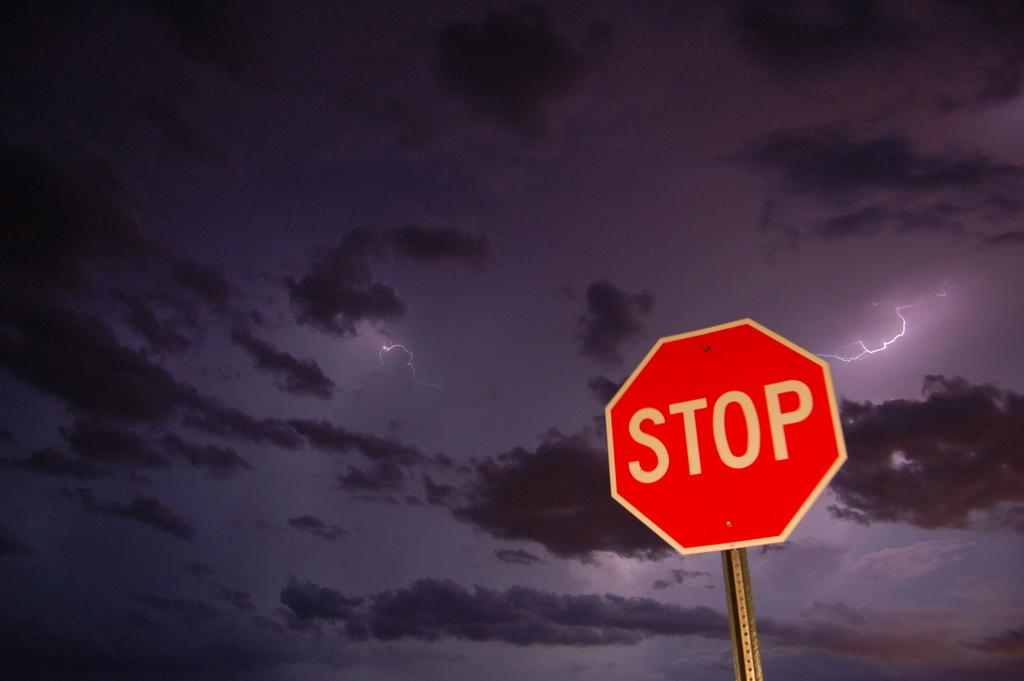What is the main object in the image? There is a STOP sign board in the image. What is the condition of the sky in the image? The sky is cloudy in the image. What type of jam is being spread on the babies in the image? There are no babies or jam present in the image. The image only features a STOP sign board and a cloudy sky. 